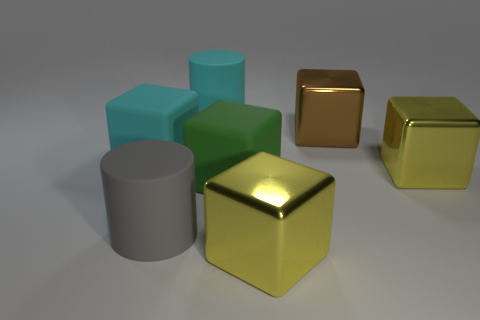Subtract all green cubes. How many cubes are left? 4 Subtract all big brown cubes. How many cubes are left? 4 Subtract all gray cubes. Subtract all cyan cylinders. How many cubes are left? 5 Add 1 tiny purple matte spheres. How many objects exist? 8 Subtract all cylinders. How many objects are left? 5 Subtract all big cyan matte cylinders. Subtract all yellow metal objects. How many objects are left? 4 Add 1 big shiny cubes. How many big shiny cubes are left? 4 Add 3 big yellow metal cubes. How many big yellow metal cubes exist? 5 Subtract 0 purple spheres. How many objects are left? 7 